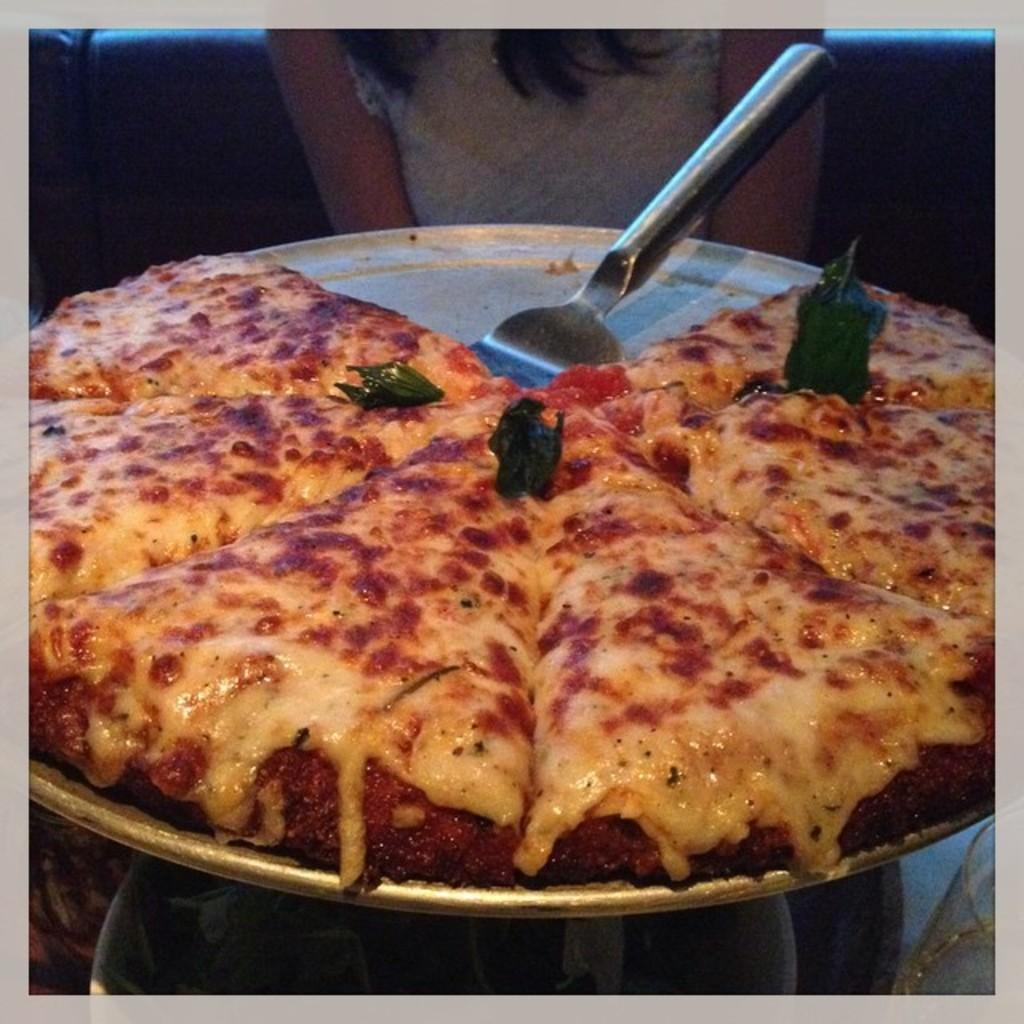What type of food is present on the plate in the image? There are many slices of pizza on a big plate in the image. Can you describe the person visible in the image? Unfortunately, the provided facts do not mention any details about the person in the image. How many slices of pizza are on the plate? The number of slices of pizza on the plate is not specified in the provided facts. What type of board is being used by the person to fan themselves in the image? There is no person using a board to fan themselves in the image. 